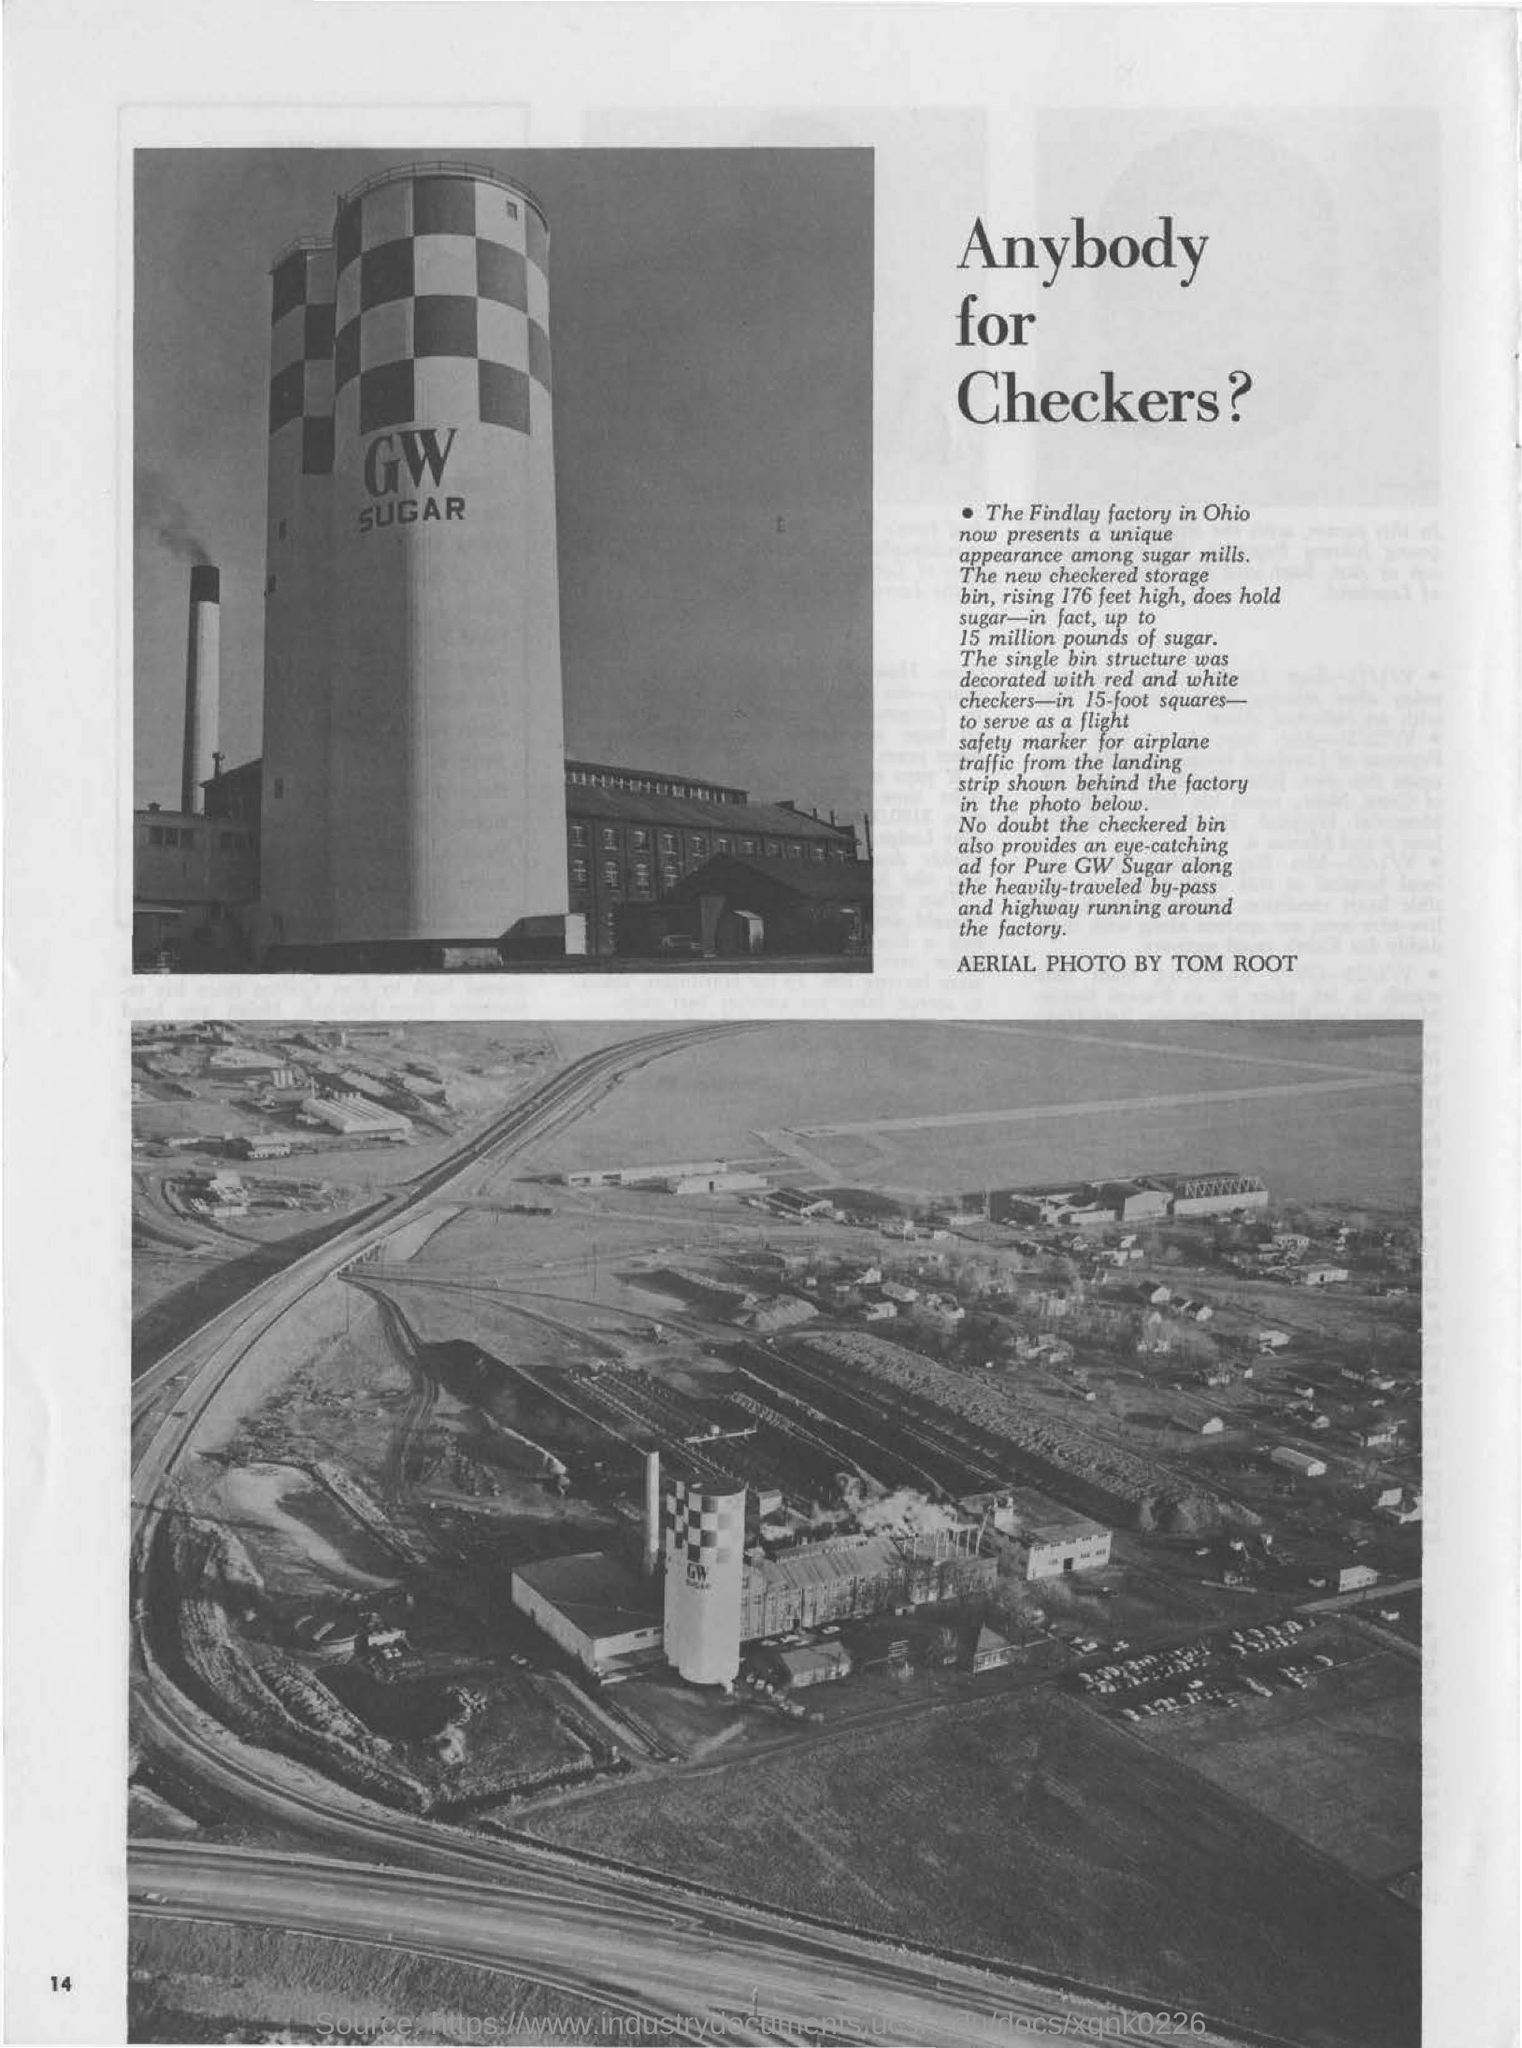Who has clicked the Aerial Photo ?
Provide a succinct answer. TOM ROOT. What is the height of the new checkered storage bin?
Your answer should be compact. 176 feet high. How much sugar the new checkered storage bin can hold?
Your response must be concise. Up to 15 million pounds of sugar. Which factory's storage bin is shown in the picture?
Give a very brief answer. Findlay factory. What is the head line of the news?
Your answer should be compact. Anybody for Checkers?. 